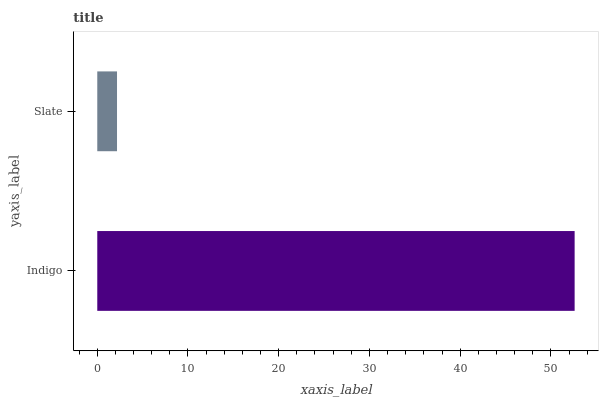Is Slate the minimum?
Answer yes or no. Yes. Is Indigo the maximum?
Answer yes or no. Yes. Is Slate the maximum?
Answer yes or no. No. Is Indigo greater than Slate?
Answer yes or no. Yes. Is Slate less than Indigo?
Answer yes or no. Yes. Is Slate greater than Indigo?
Answer yes or no. No. Is Indigo less than Slate?
Answer yes or no. No. Is Indigo the high median?
Answer yes or no. Yes. Is Slate the low median?
Answer yes or no. Yes. Is Slate the high median?
Answer yes or no. No. Is Indigo the low median?
Answer yes or no. No. 